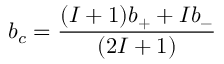<formula> <loc_0><loc_0><loc_500><loc_500>b _ { c } = \frac { ( I + 1 ) b _ { + } + I b _ { - } } { ( 2 I + 1 ) }</formula> 